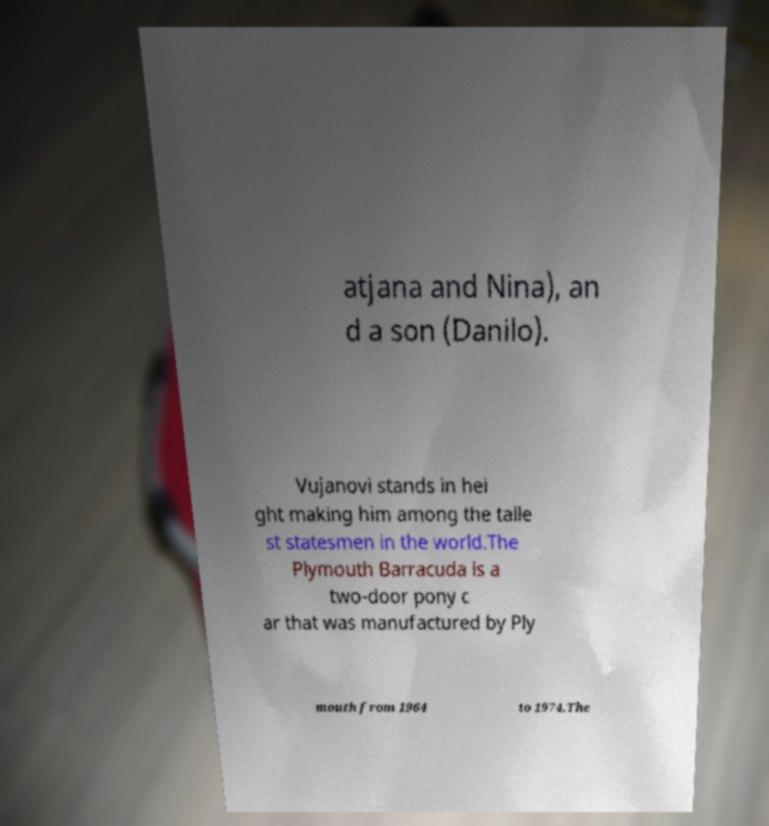I need the written content from this picture converted into text. Can you do that? atjana and Nina), an d a son (Danilo). Vujanovi stands in hei ght making him among the talle st statesmen in the world.The Plymouth Barracuda is a two-door pony c ar that was manufactured by Ply mouth from 1964 to 1974.The 